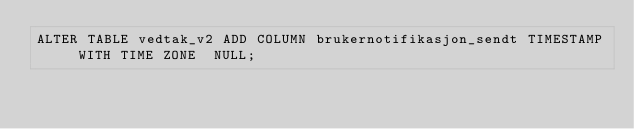<code> <loc_0><loc_0><loc_500><loc_500><_SQL_>ALTER TABLE vedtak_v2 ADD COLUMN brukernotifikasjon_sendt TIMESTAMP WITH TIME ZONE  NULL;
</code> 